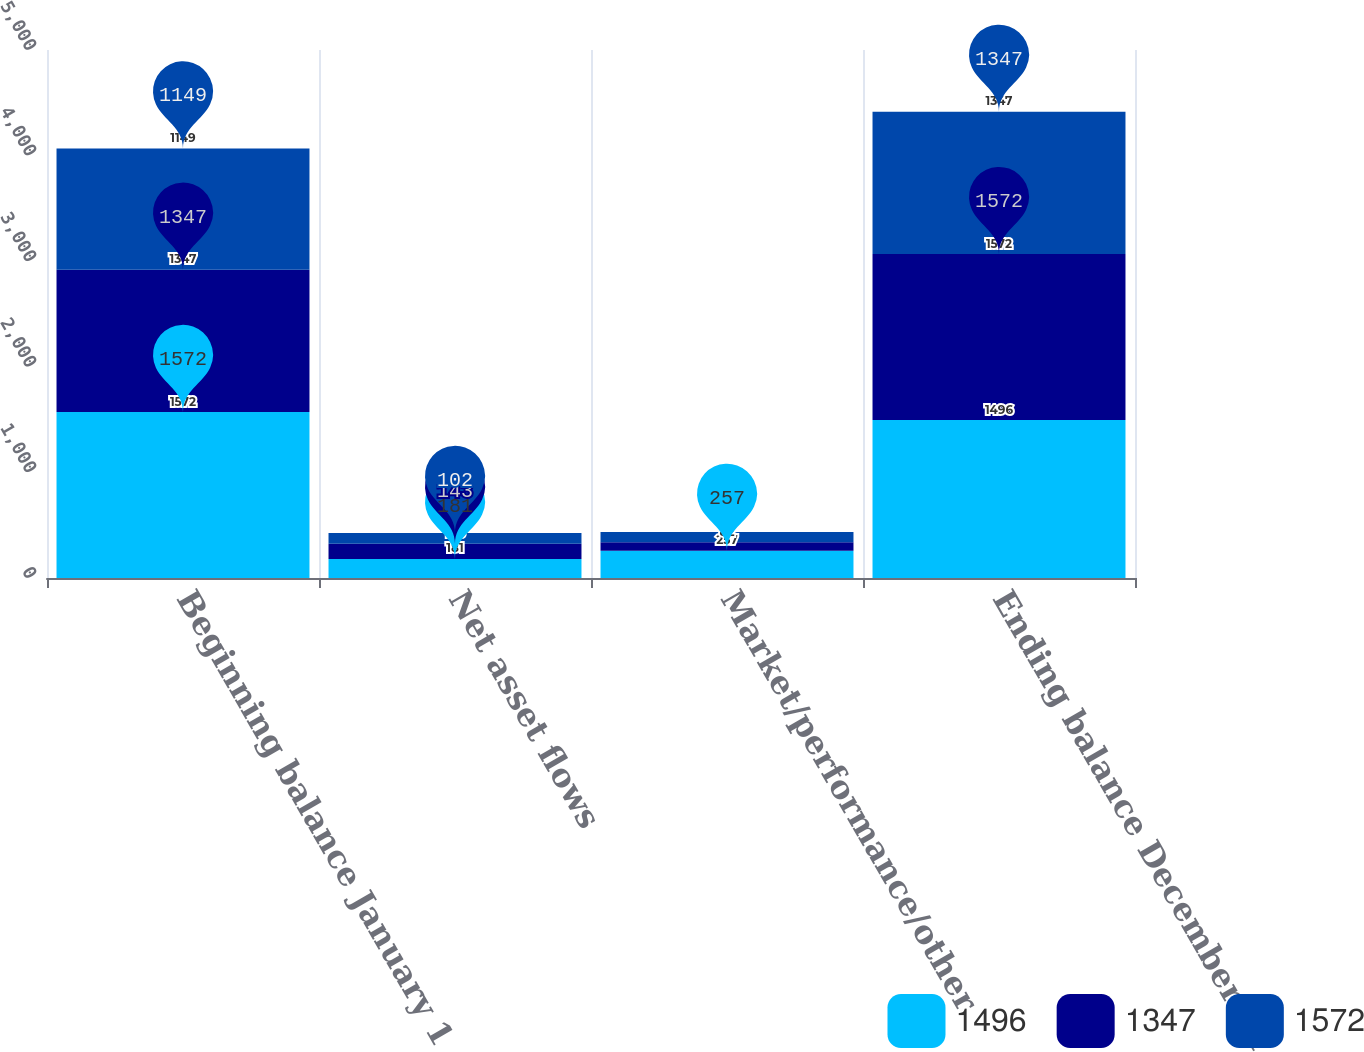Convert chart. <chart><loc_0><loc_0><loc_500><loc_500><stacked_bar_chart><ecel><fcel>Beginning balance January 1<fcel>Net asset flows<fcel>Market/performance/other<fcel>Ending balance December 31<nl><fcel>1496<fcel>1572<fcel>181<fcel>257<fcel>1496<nl><fcel>1347<fcel>1347<fcel>143<fcel>82<fcel>1572<nl><fcel>1572<fcel>1149<fcel>102<fcel>96<fcel>1347<nl></chart> 